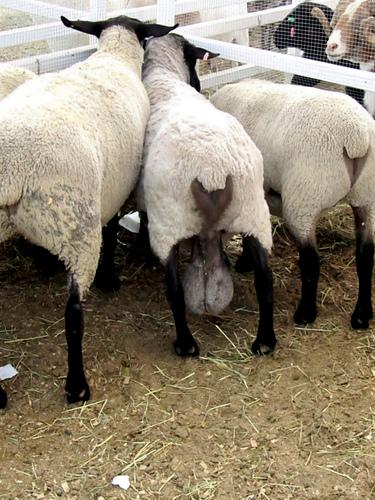Question: what color are the three lambs in the foreground in the middle of the photo?
Choices:
A. Gray and white.
B. Black and gold.
C. White and brown.
D. Black and white.
Answer with the letter. Answer: D Question: how many animals are in this photo?
Choices:
A. Four.
B. Three.
C. Two.
D. Six.
Answer with the letter. Answer: D Question: what are the lambs standing on?
Choices:
A. On the grass.
B. On the ground.
C. On the floor.
D. Dirt.
Answer with the letter. Answer: D Question: when is this scene taking place?
Choices:
A. At lunch time.
B. At noon.
C. Day time.
D. At nighttime.
Answer with the letter. Answer: C Question: where is this scene taking place?
Choices:
A. At a park.
B. At the tennis court.
C. At the poolside.
D. At the zoo.
Answer with the letter. Answer: D Question: what are the lambs standing in?
Choices:
A. In a building.
B. In a field.
C. In the mud.
D. Wooden pen.
Answer with the letter. Answer: D 